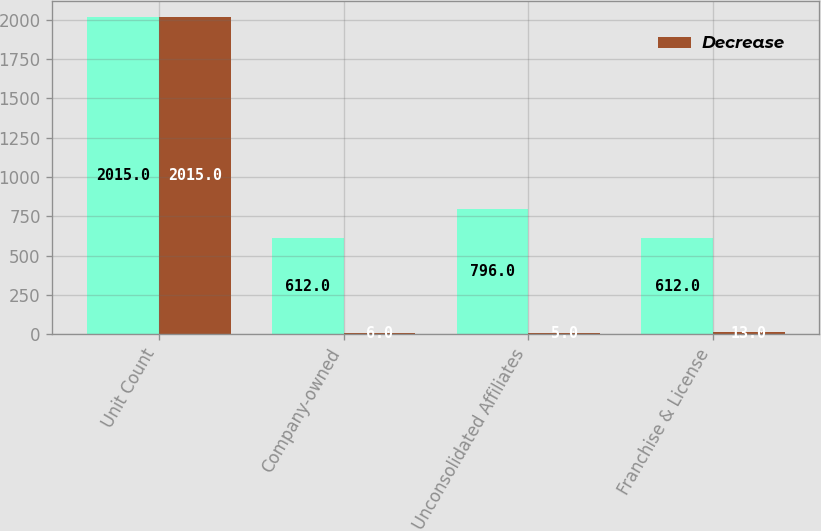Convert chart to OTSL. <chart><loc_0><loc_0><loc_500><loc_500><stacked_bar_chart><ecel><fcel>Unit Count<fcel>Company-owned<fcel>Unconsolidated Affiliates<fcel>Franchise & License<nl><fcel>nan<fcel>2015<fcel>612<fcel>796<fcel>612<nl><fcel>Decrease<fcel>2015<fcel>6<fcel>5<fcel>13<nl></chart> 